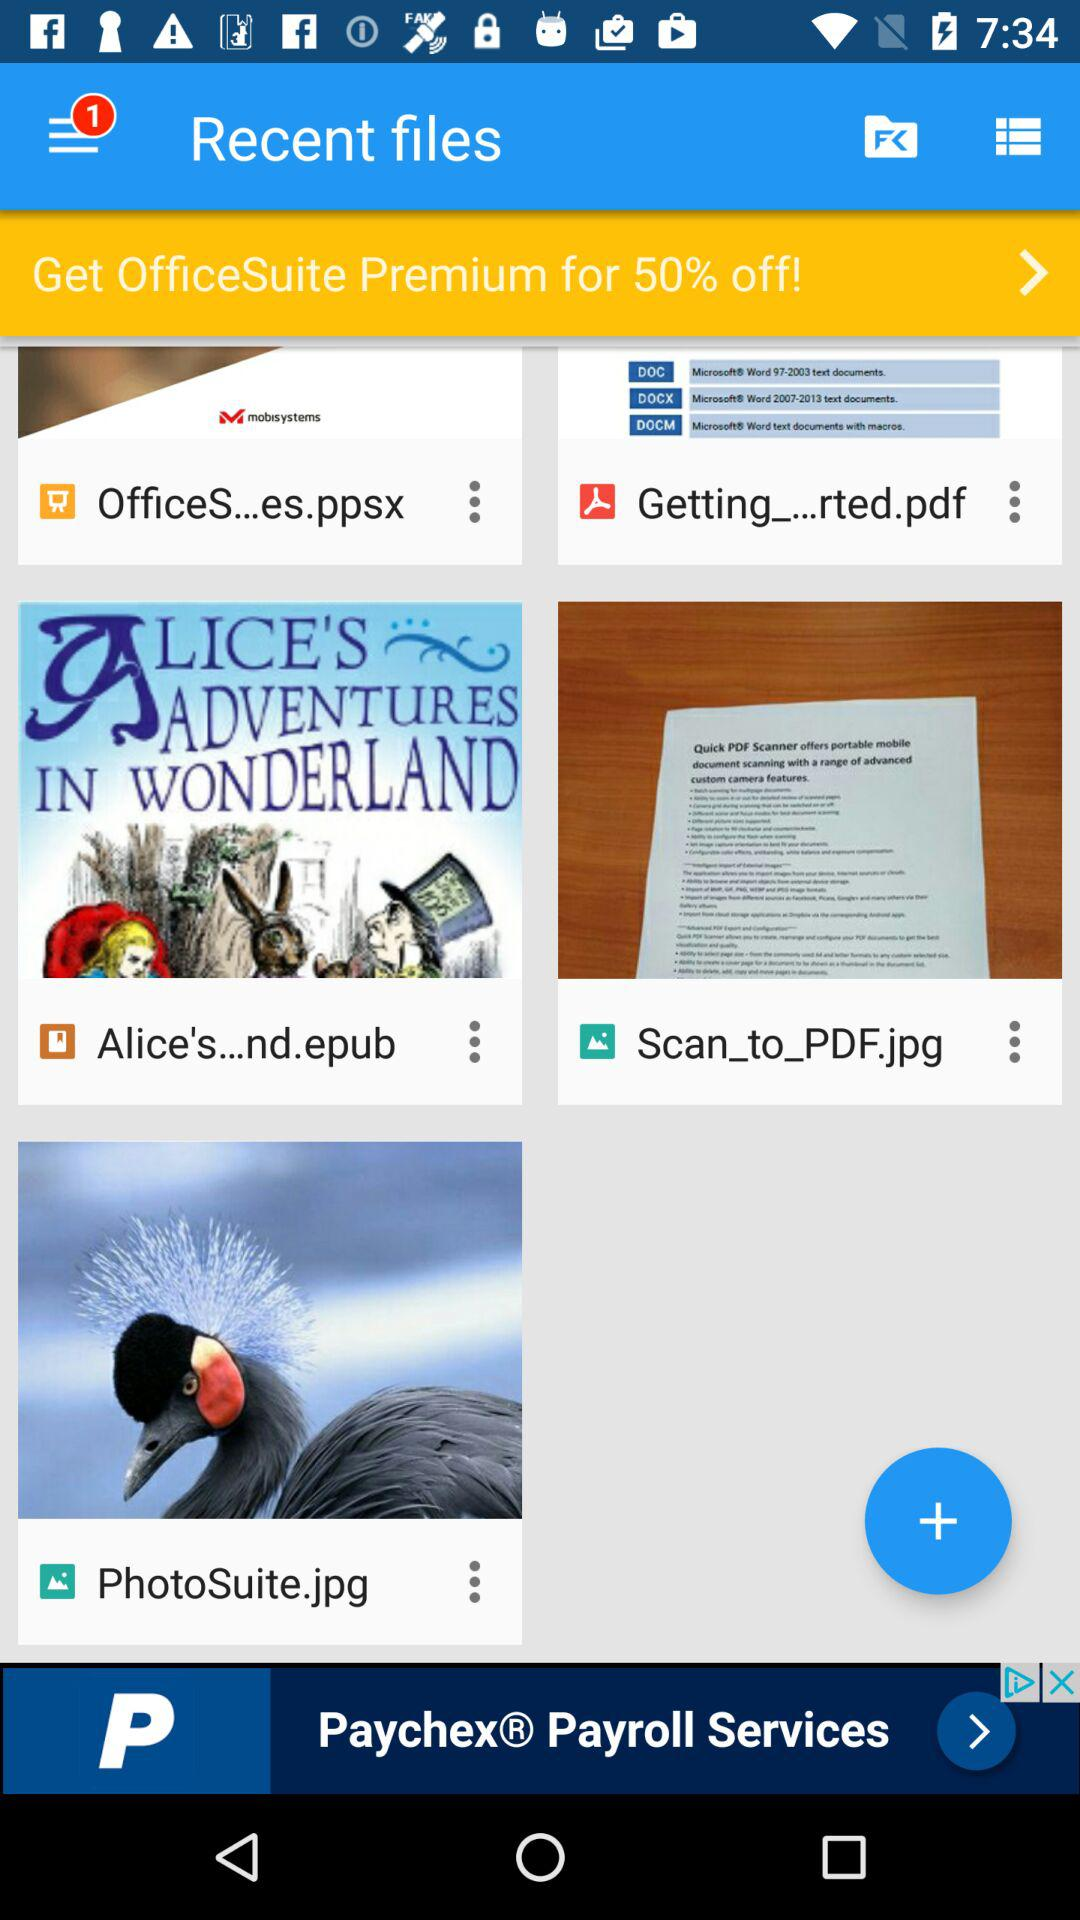What is the discount on "OfficeSuite Premium"? The discount on "OfficeSuite Premium" is 50% off. 